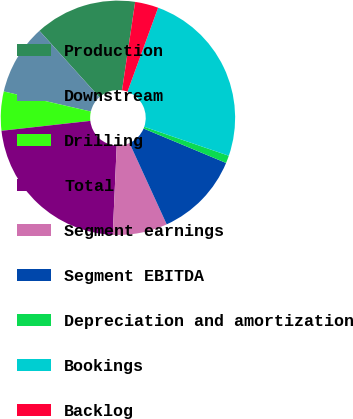Convert chart. <chart><loc_0><loc_0><loc_500><loc_500><pie_chart><fcel>Production<fcel>Downstream<fcel>Drilling<fcel>Total<fcel>Segment earnings<fcel>Segment EBITDA<fcel>Depreciation and amortization<fcel>Bookings<fcel>Backlog<nl><fcel>14.03%<fcel>9.71%<fcel>5.38%<fcel>22.52%<fcel>7.54%<fcel>11.87%<fcel>1.05%<fcel>24.68%<fcel>3.22%<nl></chart> 